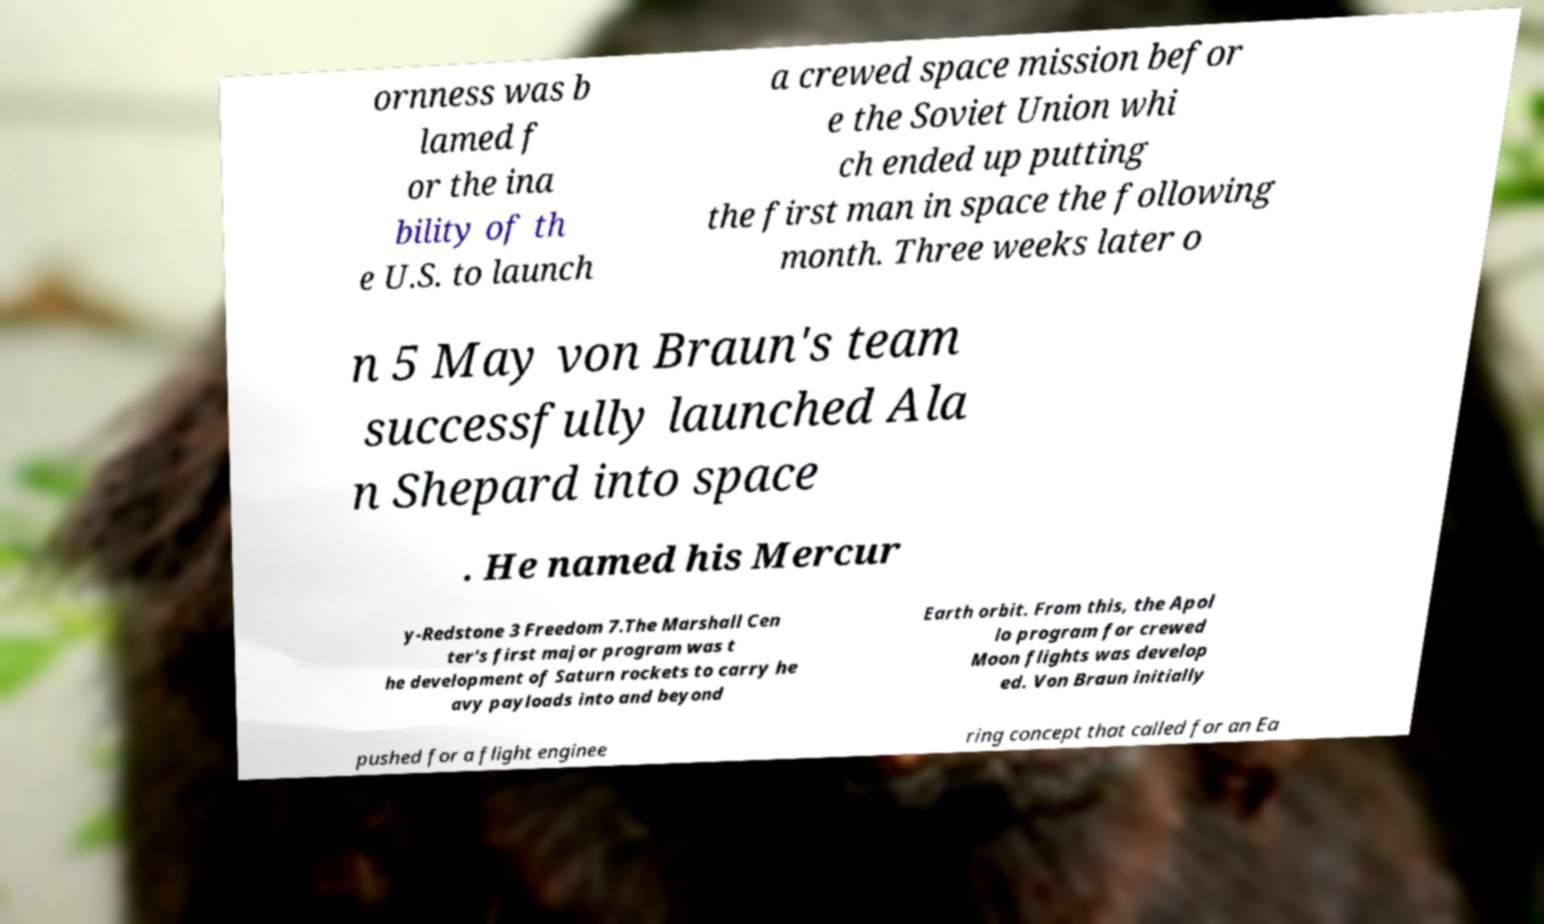Could you extract and type out the text from this image? ornness was b lamed f or the ina bility of th e U.S. to launch a crewed space mission befor e the Soviet Union whi ch ended up putting the first man in space the following month. Three weeks later o n 5 May von Braun's team successfully launched Ala n Shepard into space . He named his Mercur y-Redstone 3 Freedom 7.The Marshall Cen ter's first major program was t he development of Saturn rockets to carry he avy payloads into and beyond Earth orbit. From this, the Apol lo program for crewed Moon flights was develop ed. Von Braun initially pushed for a flight enginee ring concept that called for an Ea 